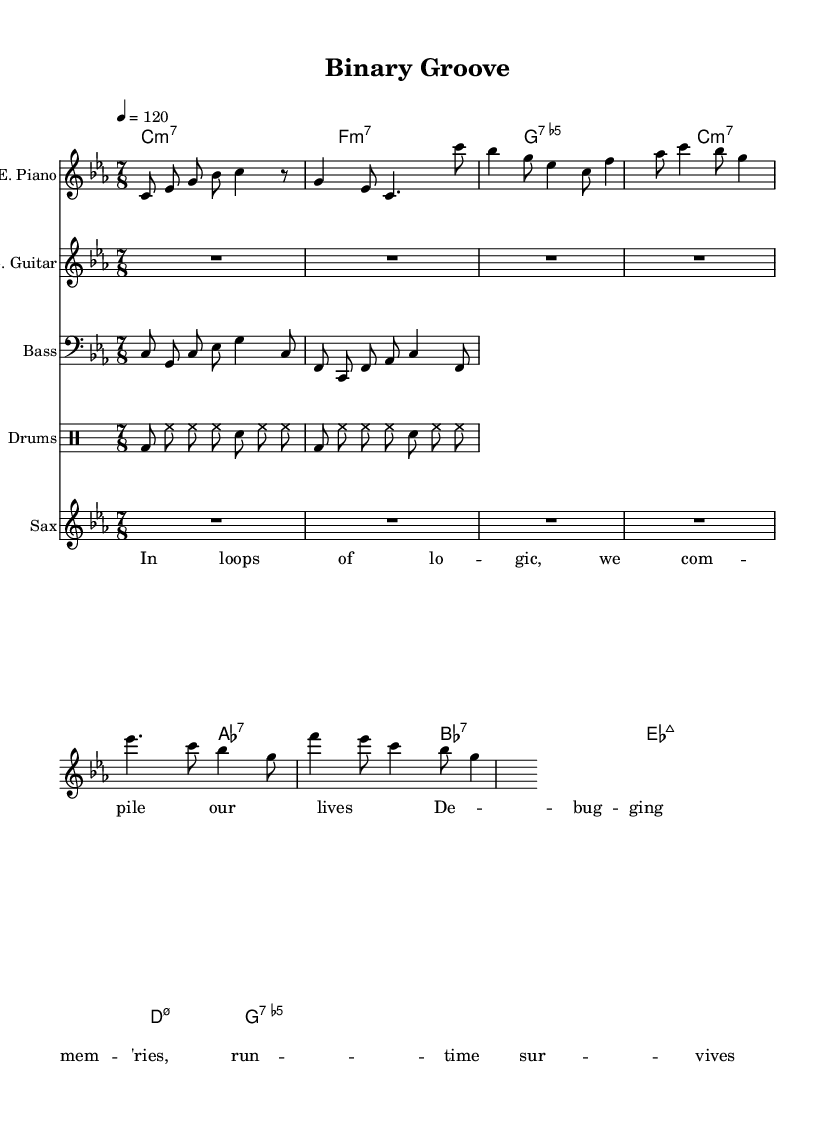What is the key signature of this music? The key signature is C minor, indicated by three flats in the key signature at the beginning of the score.
Answer: C minor What is the time signature of this music? The time signature is indicated right after the key signature, showing a division of beats into seven eighth notes per measure, which means it is seven-eighth time.
Answer: 7/8 What is the tempo marking for the piece? The tempo marking is 4 beats per minute, indicated as "4 = 120," which specifies the tempo in beats per minute at the start of the score.
Answer: 120 How many measures are in the electric piano part? The electric piano section is viewed at a glance, and counting the endings of the phrases, it consists of a few measures, specifically five measures, all of which are recognizable in the notation.
Answer: 5 Which chord is played in the first measure? The first measure indicates a C minor seventh chord, identifiable by the chord name 'c:m7' before the first measure of the chord names section at the top.
Answer: c:m7 What instruments are used in this composition? The score outlines multiple instruments by listing them individually including electric piano, electric guitar, bass guitar, drums, and saxophone, each labeled clearly in their respective staves.
Answer: Electric piano, electric guitar, bass guitar, drums, saxophone What lyrical theme is being explored in the verse? The lyrics describe themes related to computing and memories, drawn from the text of the verse which reflects debugging and the significance of logic in life, indicated in the lyric section.
Answer: Logic and memory 